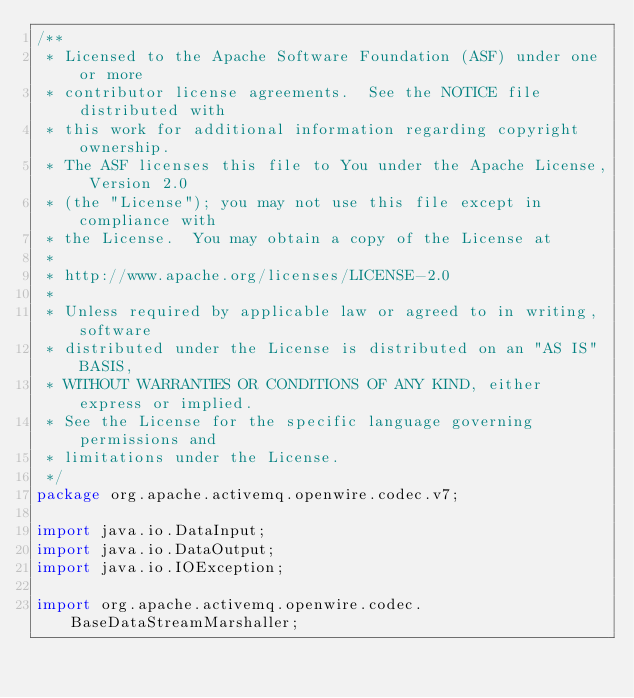Convert code to text. <code><loc_0><loc_0><loc_500><loc_500><_Java_>/**
 * Licensed to the Apache Software Foundation (ASF) under one or more
 * contributor license agreements.  See the NOTICE file distributed with
 * this work for additional information regarding copyright ownership.
 * The ASF licenses this file to You under the Apache License, Version 2.0
 * (the "License"); you may not use this file except in compliance with
 * the License.  You may obtain a copy of the License at
 *
 * http://www.apache.org/licenses/LICENSE-2.0
 *
 * Unless required by applicable law or agreed to in writing, software
 * distributed under the License is distributed on an "AS IS" BASIS,
 * WITHOUT WARRANTIES OR CONDITIONS OF ANY KIND, either express or implied.
 * See the License for the specific language governing permissions and
 * limitations under the License.
 */
package org.apache.activemq.openwire.codec.v7;

import java.io.DataInput;
import java.io.DataOutput;
import java.io.IOException;

import org.apache.activemq.openwire.codec.BaseDataStreamMarshaller;</code> 